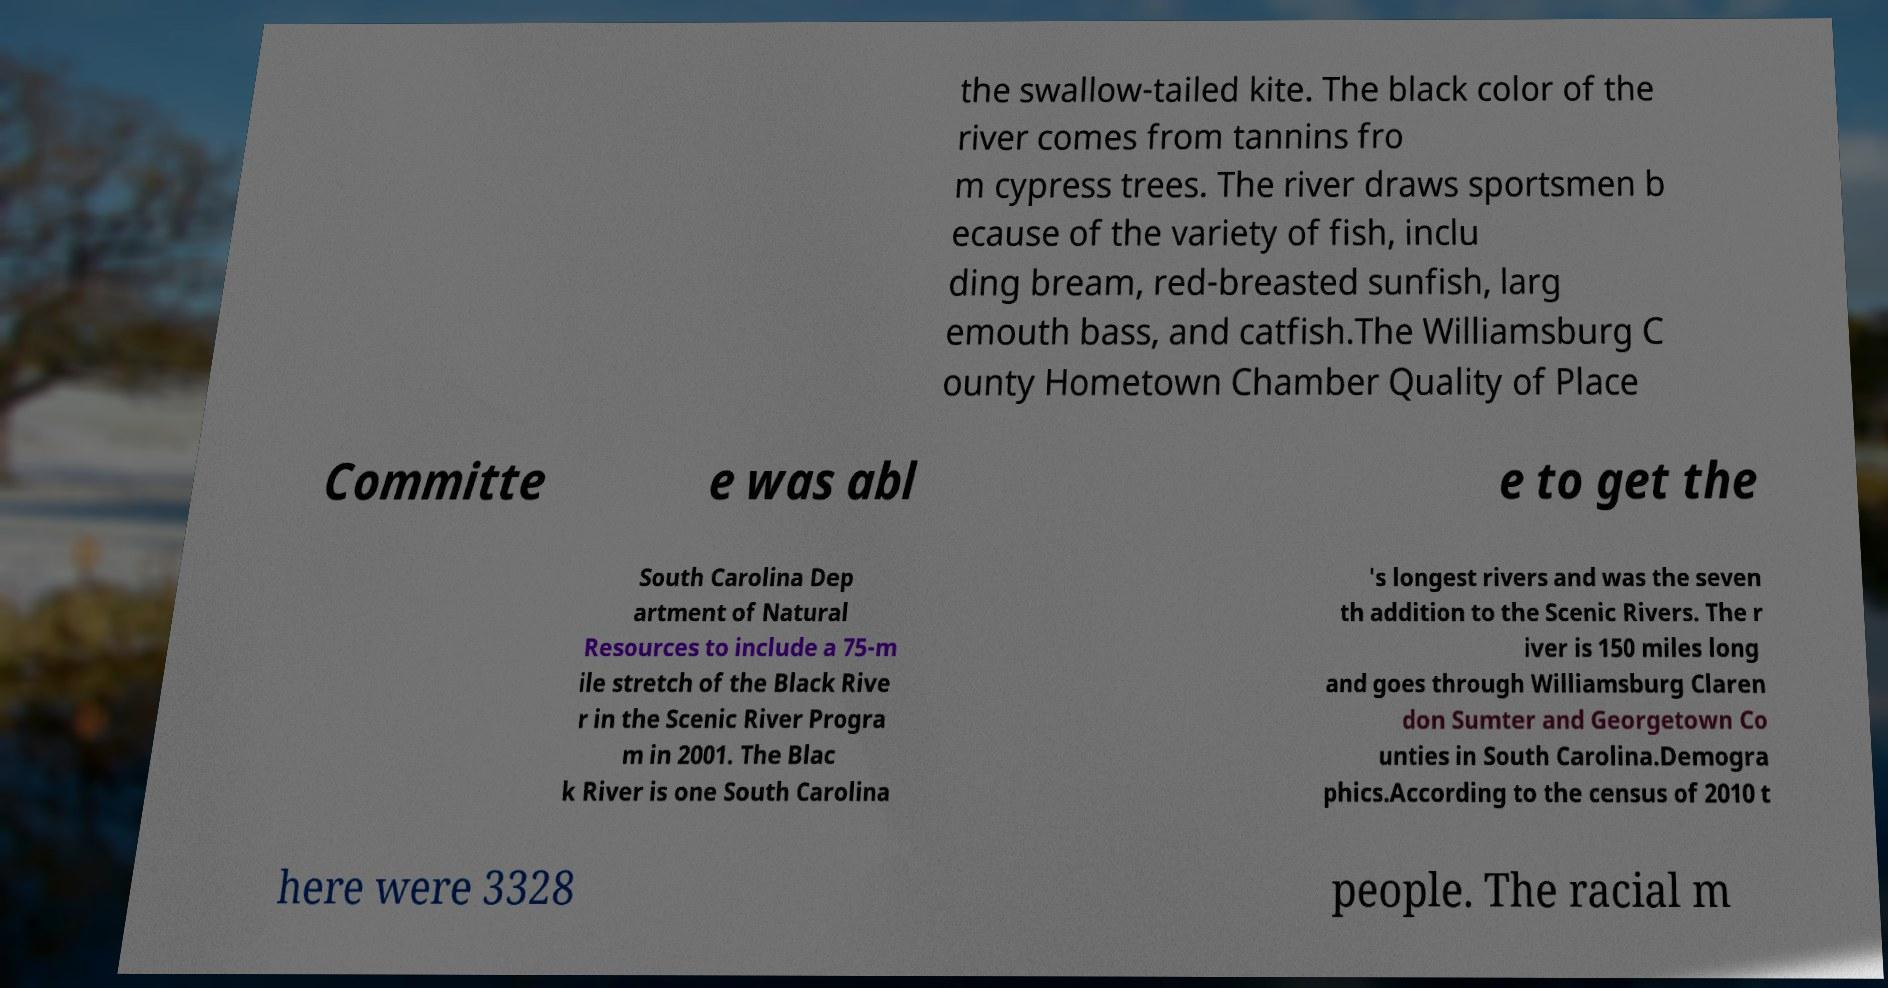I need the written content from this picture converted into text. Can you do that? the swallow-tailed kite. The black color of the river comes from tannins fro m cypress trees. The river draws sportsmen b ecause of the variety of fish, inclu ding bream, red-breasted sunfish, larg emouth bass, and catfish.The Williamsburg C ounty Hometown Chamber Quality of Place Committe e was abl e to get the South Carolina Dep artment of Natural Resources to include a 75-m ile stretch of the Black Rive r in the Scenic River Progra m in 2001. The Blac k River is one South Carolina 's longest rivers and was the seven th addition to the Scenic Rivers. The r iver is 150 miles long and goes through Williamsburg Claren don Sumter and Georgetown Co unties in South Carolina.Demogra phics.According to the census of 2010 t here were 3328 people. The racial m 